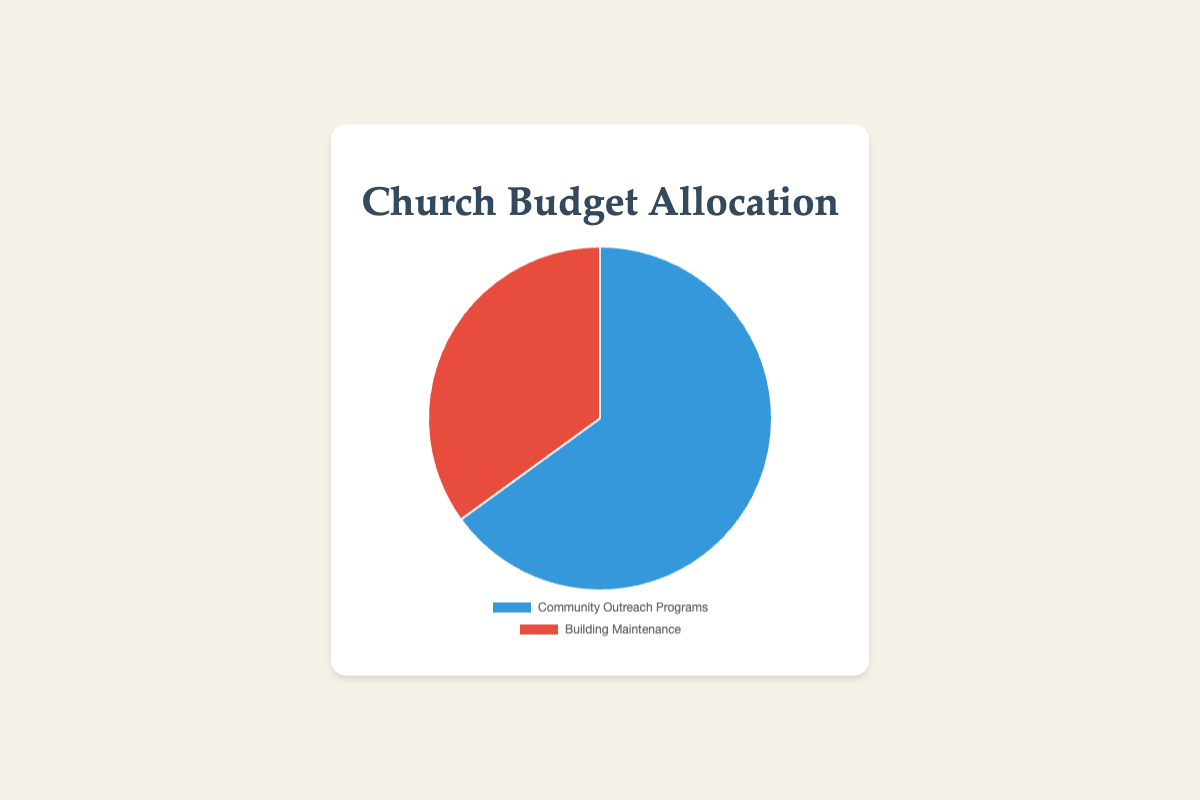What percentage of the church budget is allocated to Community Outreach Programs? The pie chart visually indicates that 65% of the church budget is allocated to Community Outreach Programs. You can see this by looking at the size of the slice labeled "Community Outreach Programs" and the provided data.
Answer: 65% What percentage of the church budget is spent on Building Maintenance? The pie chart shows that 35% of the church budget is allocated to Building Maintenance. You can find this information by observing the size of the slice labeled "Building Maintenance" and from the provided data.
Answer: 35% How much more is allocated to Community Outreach Programs compared to Building Maintenance? To find the difference, subtract the percentage allocated to Building Maintenance from the percentage allocated to Community Outreach Programs. 65% - 35% = 30%. Thus, 30% more is allocated to Community Outreach Programs.
Answer: 30% Which category receives a greater portion of the budget? By comparing the sizes of the slices in the pie chart, we can see that Community Outreach Programs receive a greater portion of the budget with 65% compared to Building Maintenance’s 35%.
Answer: Community Outreach Programs What is the ratio of the budget allocation between Community Outreach Programs and Building Maintenance? The ratio is calculated by dividing the percentage of the budget allocated to Community Outreach Programs by the percentage allocated to Building Maintenance. This gives us 65/35 which simplifies to approximately 1.86:1.
Answer: 1.86:1 If the total church budget is $100,000, how much money is allocated to Community Outreach Programs? Calculate 65% of $100,000 by multiplying them (0.65 * 100,000). Therefore, $65,000 is allocated to Community Outreach Programs.
Answer: $65,000 If next year the budget for Building Maintenance decreases to 25% while the total budget remains the same, what will be the new percentage allocation for Community Outreach Programs? If Building Maintenance takes up 25% of the budget next year and the total budget is 100%, the remaining for Community Outreach Programs will be 100% - 25% = 75%.
Answer: 75% Considering a hypothetical scenario where the total budget is reduced by 20%, and the initial budget was $80,000, what will be the amounts allocated to Community Outreach Programs and Building Maintenance? A 20% reduction of an $80,000 budget results in a new budget of $64,000. Calculating the amounts, 65% of $64,000 = 0.65 * 64,000 = $41,600 and 35% of $64,000 = 0.35 * 64,000 = $22,400. Thus, $41,600 is allocated to Community Outreach Programs, and $22,400 is allocated to Building Maintenance.
Answer: $41,600 and $22,400 